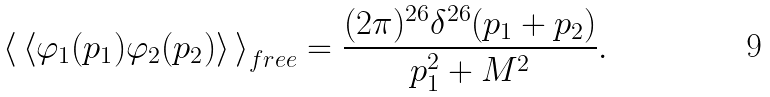<formula> <loc_0><loc_0><loc_500><loc_500>\left \langle \, \left \langle \varphi _ { 1 } ( p _ { 1 } ) \varphi _ { 2 } ( p _ { 2 } ) \right \rangle \, \right \rangle _ { f r e e } = \frac { ( 2 \pi ) ^ { 2 6 } \delta ^ { 2 6 } ( p _ { 1 } + p _ { 2 } ) } { p _ { 1 } ^ { 2 } + M ^ { 2 } } .</formula> 